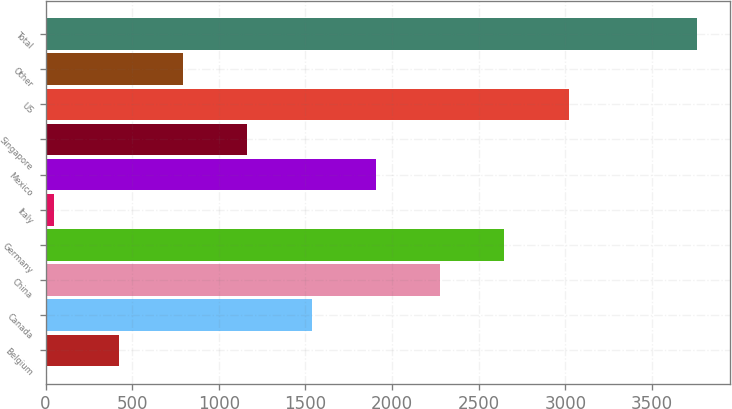<chart> <loc_0><loc_0><loc_500><loc_500><bar_chart><fcel>Belgium<fcel>Canada<fcel>China<fcel>Germany<fcel>Italy<fcel>Mexico<fcel>Singapore<fcel>US<fcel>Other<fcel>Total<nl><fcel>422.1<fcel>1535.4<fcel>2277.6<fcel>2648.7<fcel>51<fcel>1906.5<fcel>1164.3<fcel>3019.8<fcel>793.2<fcel>3762<nl></chart> 